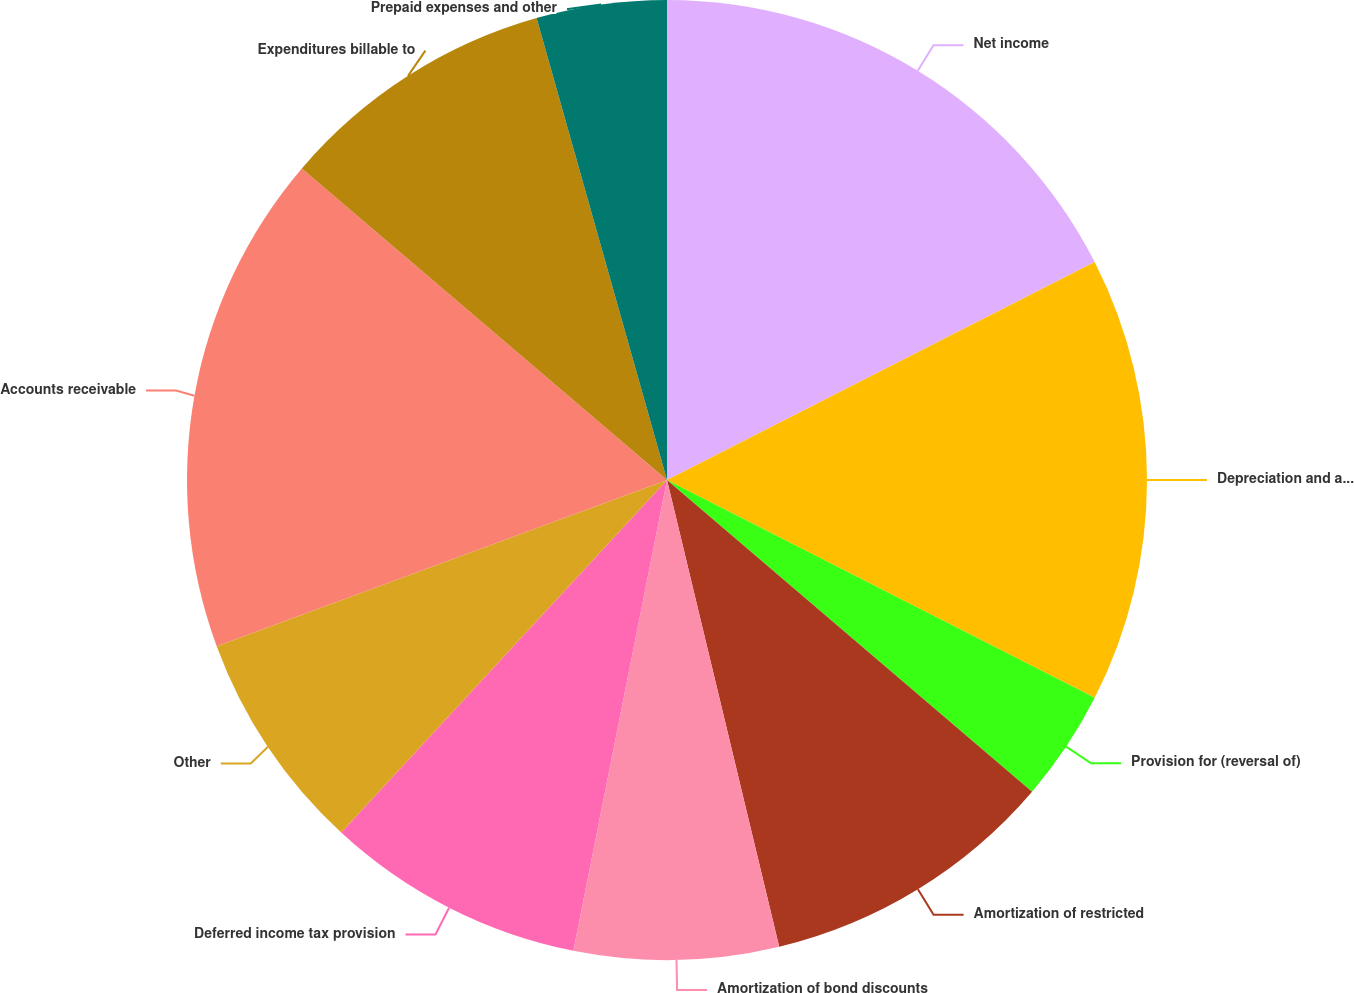Convert chart. <chart><loc_0><loc_0><loc_500><loc_500><pie_chart><fcel>Net income<fcel>Depreciation and amortization<fcel>Provision for (reversal of)<fcel>Amortization of restricted<fcel>Amortization of bond discounts<fcel>Deferred income tax provision<fcel>Other<fcel>Accounts receivable<fcel>Expenditures billable to<fcel>Prepaid expenses and other<nl><fcel>17.5%<fcel>15.0%<fcel>3.75%<fcel>10.0%<fcel>6.88%<fcel>8.75%<fcel>7.5%<fcel>16.87%<fcel>9.38%<fcel>4.38%<nl></chart> 